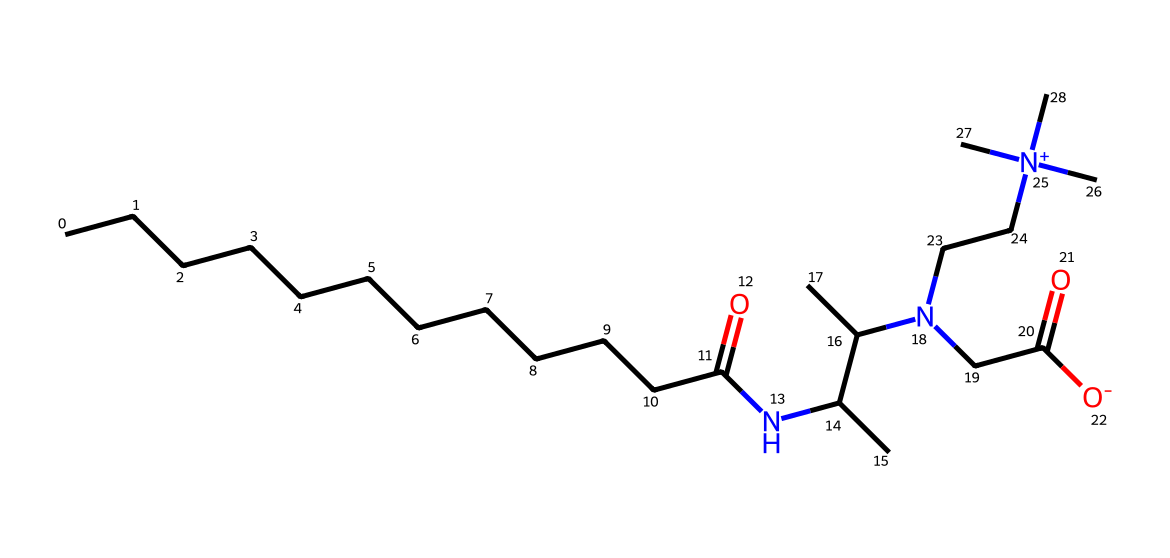what is the main functional group present in cocamidopropyl betaine? The functional groups in cocamidopropyl betaine can be identified by looking at the chemical structure, specifically the amide (–C(=O)N–) and quaternary ammonium group (N+). The presence of these groups indicates the compound's classification as a surfactant.
Answer: amide and quaternary ammonium how many carbon atoms are in the chemical structure of cocamidopropyl betaine? Counting the carbon atoms in the structure involves identifying all carbon in the chain and the functional groups. In this case, there are a total of 15 carbon atoms present in the structure.
Answer: 15 what is the charge of the terminal nitrogen in cocamidopropyl betaine? The terminal nitrogen in cocamidopropyl betaine can be recognized as a quaternary ammonium due to its positive charge (N+), forming an electrostatically balanced structure.
Answer: positive is cocamidopropyl betaine a mild surfactant? The chemical structure, showing both hydrophobic (carbon chains) and hydrophilic (amido group) segments, indicates that it has properties that make it suitable as a mild surfactant suitable for skin-care use.
Answer: yes which part of cocamidopropyl betaine contributes to its surfactant properties? The long hydrophobic carbon chain provides the lipophilic nature, while the hydrophilic amide portion allows interaction with water. Together, they reduce surface tension, which is essential for surfactants.
Answer: long carbon chain and hydrophilic amide 